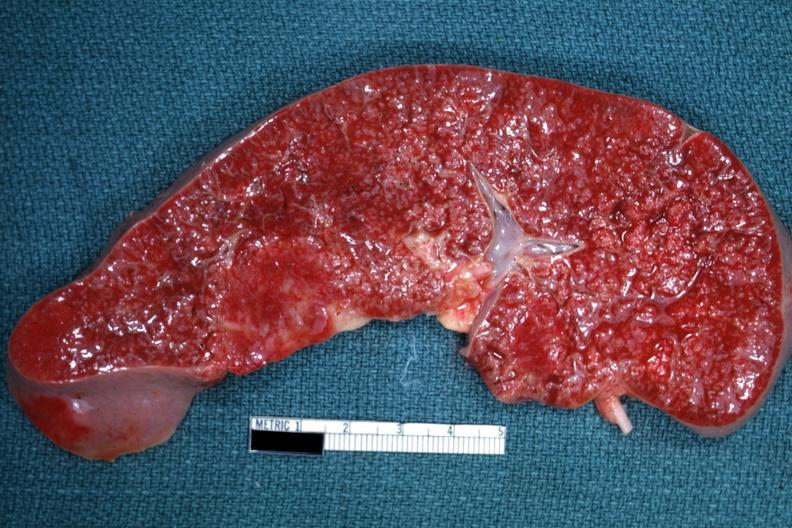s spleen present?
Answer the question using a single word or phrase. Yes 